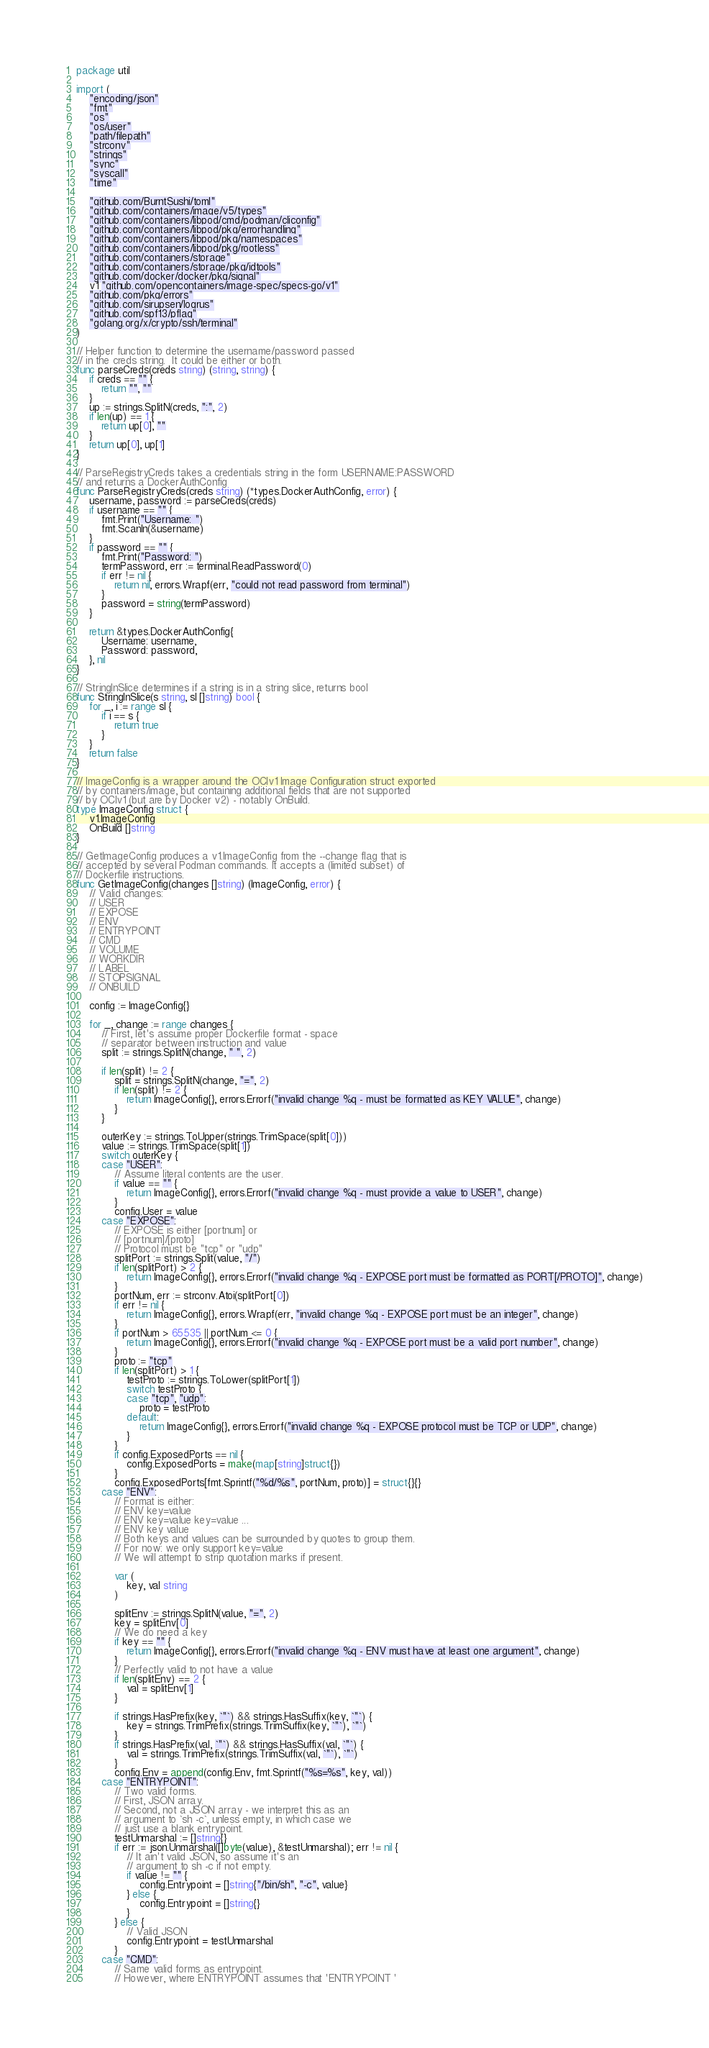<code> <loc_0><loc_0><loc_500><loc_500><_Go_>package util

import (
	"encoding/json"
	"fmt"
	"os"
	"os/user"
	"path/filepath"
	"strconv"
	"strings"
	"sync"
	"syscall"
	"time"

	"github.com/BurntSushi/toml"
	"github.com/containers/image/v5/types"
	"github.com/containers/libpod/cmd/podman/cliconfig"
	"github.com/containers/libpod/pkg/errorhandling"
	"github.com/containers/libpod/pkg/namespaces"
	"github.com/containers/libpod/pkg/rootless"
	"github.com/containers/storage"
	"github.com/containers/storage/pkg/idtools"
	"github.com/docker/docker/pkg/signal"
	v1 "github.com/opencontainers/image-spec/specs-go/v1"
	"github.com/pkg/errors"
	"github.com/sirupsen/logrus"
	"github.com/spf13/pflag"
	"golang.org/x/crypto/ssh/terminal"
)

// Helper function to determine the username/password passed
// in the creds string.  It could be either or both.
func parseCreds(creds string) (string, string) {
	if creds == "" {
		return "", ""
	}
	up := strings.SplitN(creds, ":", 2)
	if len(up) == 1 {
		return up[0], ""
	}
	return up[0], up[1]
}

// ParseRegistryCreds takes a credentials string in the form USERNAME:PASSWORD
// and returns a DockerAuthConfig
func ParseRegistryCreds(creds string) (*types.DockerAuthConfig, error) {
	username, password := parseCreds(creds)
	if username == "" {
		fmt.Print("Username: ")
		fmt.Scanln(&username)
	}
	if password == "" {
		fmt.Print("Password: ")
		termPassword, err := terminal.ReadPassword(0)
		if err != nil {
			return nil, errors.Wrapf(err, "could not read password from terminal")
		}
		password = string(termPassword)
	}

	return &types.DockerAuthConfig{
		Username: username,
		Password: password,
	}, nil
}

// StringInSlice determines if a string is in a string slice, returns bool
func StringInSlice(s string, sl []string) bool {
	for _, i := range sl {
		if i == s {
			return true
		}
	}
	return false
}

// ImageConfig is a wrapper around the OCIv1 Image Configuration struct exported
// by containers/image, but containing additional fields that are not supported
// by OCIv1 (but are by Docker v2) - notably OnBuild.
type ImageConfig struct {
	v1.ImageConfig
	OnBuild []string
}

// GetImageConfig produces a v1.ImageConfig from the --change flag that is
// accepted by several Podman commands. It accepts a (limited subset) of
// Dockerfile instructions.
func GetImageConfig(changes []string) (ImageConfig, error) {
	// Valid changes:
	// USER
	// EXPOSE
	// ENV
	// ENTRYPOINT
	// CMD
	// VOLUME
	// WORKDIR
	// LABEL
	// STOPSIGNAL
	// ONBUILD

	config := ImageConfig{}

	for _, change := range changes {
		// First, let's assume proper Dockerfile format - space
		// separator between instruction and value
		split := strings.SplitN(change, " ", 2)

		if len(split) != 2 {
			split = strings.SplitN(change, "=", 2)
			if len(split) != 2 {
				return ImageConfig{}, errors.Errorf("invalid change %q - must be formatted as KEY VALUE", change)
			}
		}

		outerKey := strings.ToUpper(strings.TrimSpace(split[0]))
		value := strings.TrimSpace(split[1])
		switch outerKey {
		case "USER":
			// Assume literal contents are the user.
			if value == "" {
				return ImageConfig{}, errors.Errorf("invalid change %q - must provide a value to USER", change)
			}
			config.User = value
		case "EXPOSE":
			// EXPOSE is either [portnum] or
			// [portnum]/[proto]
			// Protocol must be "tcp" or "udp"
			splitPort := strings.Split(value, "/")
			if len(splitPort) > 2 {
				return ImageConfig{}, errors.Errorf("invalid change %q - EXPOSE port must be formatted as PORT[/PROTO]", change)
			}
			portNum, err := strconv.Atoi(splitPort[0])
			if err != nil {
				return ImageConfig{}, errors.Wrapf(err, "invalid change %q - EXPOSE port must be an integer", change)
			}
			if portNum > 65535 || portNum <= 0 {
				return ImageConfig{}, errors.Errorf("invalid change %q - EXPOSE port must be a valid port number", change)
			}
			proto := "tcp"
			if len(splitPort) > 1 {
				testProto := strings.ToLower(splitPort[1])
				switch testProto {
				case "tcp", "udp":
					proto = testProto
				default:
					return ImageConfig{}, errors.Errorf("invalid change %q - EXPOSE protocol must be TCP or UDP", change)
				}
			}
			if config.ExposedPorts == nil {
				config.ExposedPorts = make(map[string]struct{})
			}
			config.ExposedPorts[fmt.Sprintf("%d/%s", portNum, proto)] = struct{}{}
		case "ENV":
			// Format is either:
			// ENV key=value
			// ENV key=value key=value ...
			// ENV key value
			// Both keys and values can be surrounded by quotes to group them.
			// For now: we only support key=value
			// We will attempt to strip quotation marks if present.

			var (
				key, val string
			)

			splitEnv := strings.SplitN(value, "=", 2)
			key = splitEnv[0]
			// We do need a key
			if key == "" {
				return ImageConfig{}, errors.Errorf("invalid change %q - ENV must have at least one argument", change)
			}
			// Perfectly valid to not have a value
			if len(splitEnv) == 2 {
				val = splitEnv[1]
			}

			if strings.HasPrefix(key, `"`) && strings.HasSuffix(key, `"`) {
				key = strings.TrimPrefix(strings.TrimSuffix(key, `"`), `"`)
			}
			if strings.HasPrefix(val, `"`) && strings.HasSuffix(val, `"`) {
				val = strings.TrimPrefix(strings.TrimSuffix(val, `"`), `"`)
			}
			config.Env = append(config.Env, fmt.Sprintf("%s=%s", key, val))
		case "ENTRYPOINT":
			// Two valid forms.
			// First, JSON array.
			// Second, not a JSON array - we interpret this as an
			// argument to `sh -c`, unless empty, in which case we
			// just use a blank entrypoint.
			testUnmarshal := []string{}
			if err := json.Unmarshal([]byte(value), &testUnmarshal); err != nil {
				// It ain't valid JSON, so assume it's an
				// argument to sh -c if not empty.
				if value != "" {
					config.Entrypoint = []string{"/bin/sh", "-c", value}
				} else {
					config.Entrypoint = []string{}
				}
			} else {
				// Valid JSON
				config.Entrypoint = testUnmarshal
			}
		case "CMD":
			// Same valid forms as entrypoint.
			// However, where ENTRYPOINT assumes that 'ENTRYPOINT '</code> 